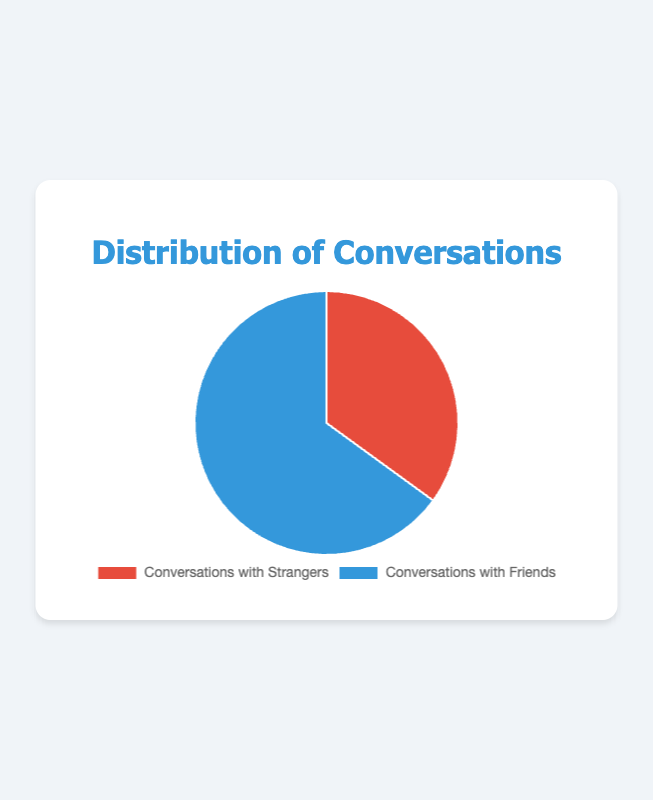What percentage of conversations are with strangers? To find the percentage of conversations with strangers, we refer to the pie chart section labeled "Conversations with Strangers." It shows the value of 35%, indicating that 35% of conversations are with strangers.
Answer: 35% What is the difference in percentage between conversations with friends and strangers? To find the difference, we subtract the percentage of conversations with strangers (35%) from the percentage of conversations with friends (65%), calculated as 65% - 35% = 30%.
Answer: 30% Which category has the larger share of conversations? Observing the pie chart, we see that "Conversations with Friends" occupies a larger segment (65%) compared to "Conversations with Strangers" (35%), so the larger share is for conversations with friends.
Answer: Conversations with Friends What is the sum of both percentages in the pie chart? The pie chart divides the total percentage into two categories: Conversations with Friends (65%) and Conversations with Strangers (35%). Summing them gives 65% + 35% = 100%.
Answer: 100% What color represents conversations with strangers in the pie chart? Referring to the visual attributes of the pie chart, the section labeled "Conversations with Strangers" is represented by the color red.
Answer: Red If one additional conversation was added to each category, how would the new percentages distribute (round to the nearest whole number)? Currently, there are 35 conversations with strangers and 65 with friends, totaling 100. Adding one conversation to each category gives 36 strangers and 66 friends, totaling 102. New percentages are: Strangers: (36/102) * 100 ≈ 35%; Friends: (66/102) * 100 ≈ 65%.
Answer: Strangers: 35%, Friends: 65% Which category takes up more than half of the pie chart? In the pie chart, "Conversations with Friends" takes up 65%, which is greater than 50%, indicating it takes up more than half of the pie chart.
Answer: Conversations with Friends How many conversations out of 100 are with friends? Since the percentage of conversations with friends is 65%, out of 100 conversations, 65 would be with friends.
Answer: 65 What would be the percentage of conversations with strangers if it increased by 10%? Currently, conversations with strangers are 35%. If it increased by 10%, it would be 35% + 10% = 45%.
Answer: 45% 